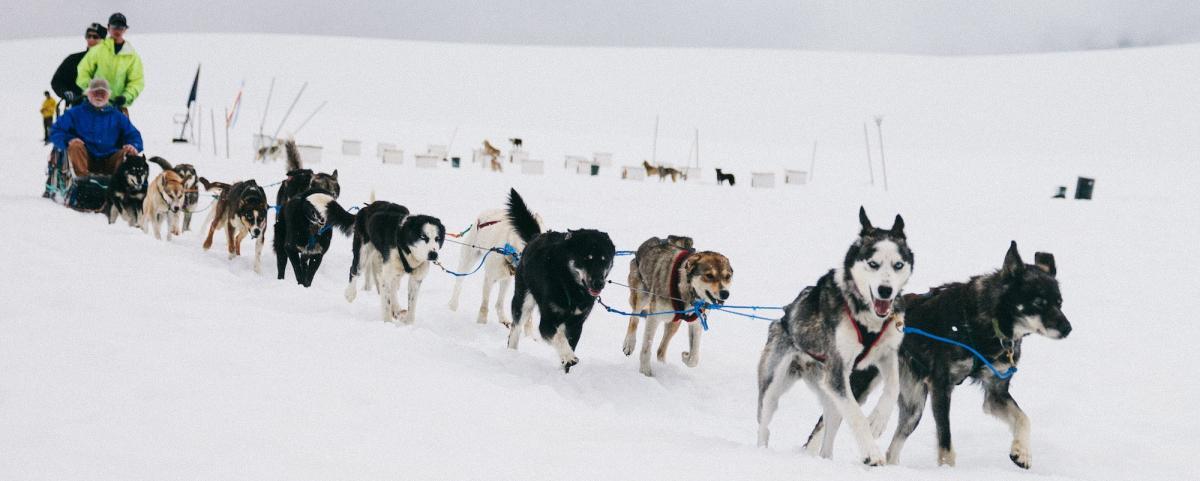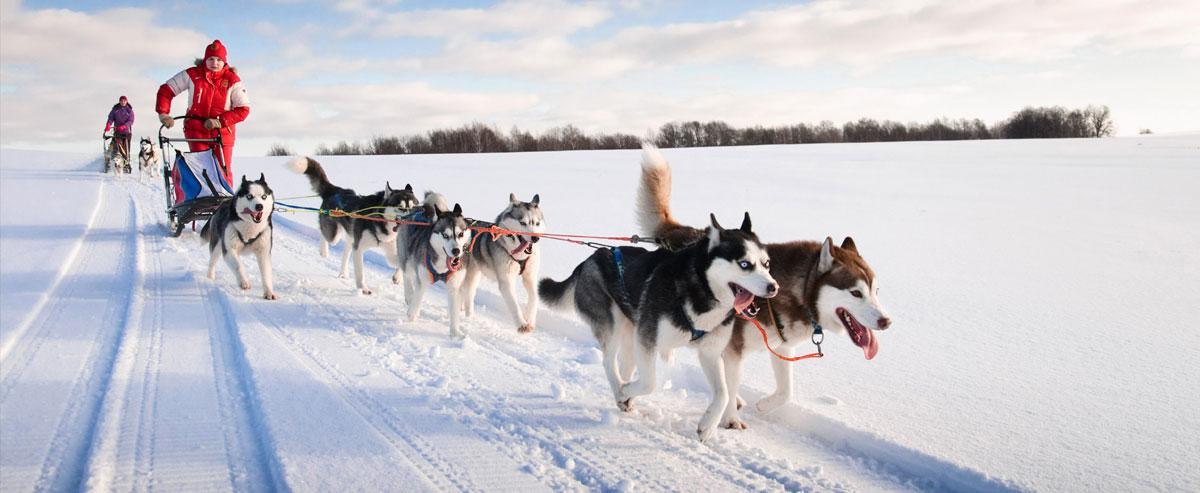The first image is the image on the left, the second image is the image on the right. Considering the images on both sides, is "The teams of dogs in the left and right images are headed in the same direction." valid? Answer yes or no. Yes. The first image is the image on the left, the second image is the image on the right. Evaluate the accuracy of this statement regarding the images: "There is only one human visible in the pair of images.". Is it true? Answer yes or no. No. 